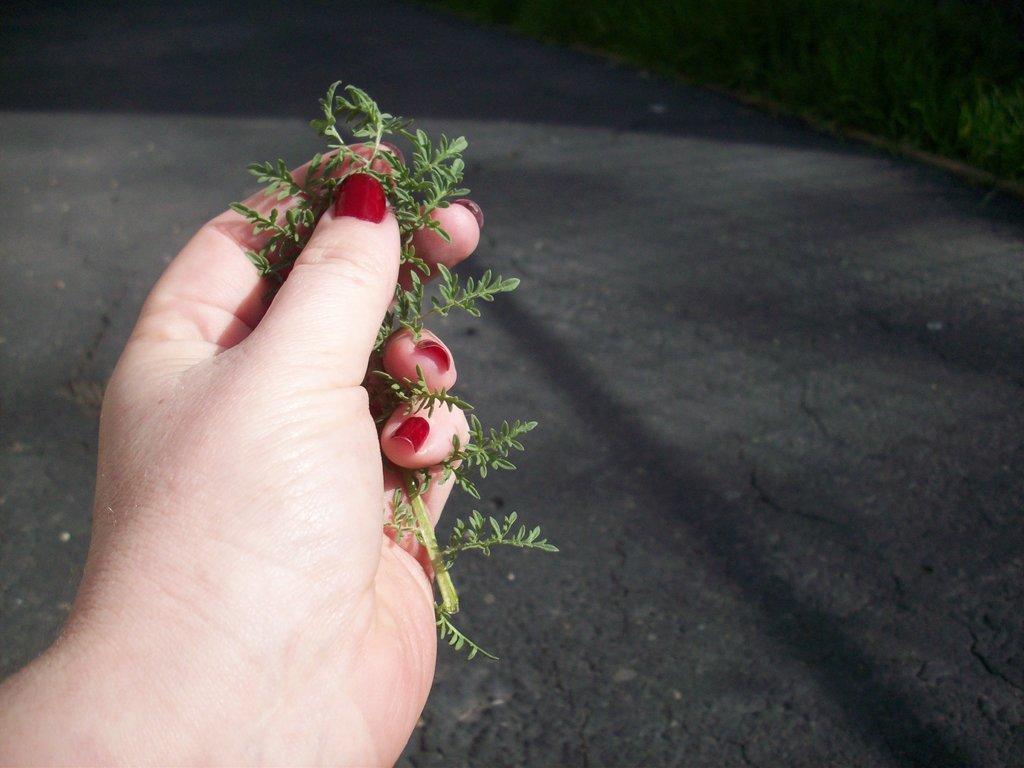Could you give a brief overview of what you see in this image? We can see plank hold with hand and we can see road. In the background we can see grass. 